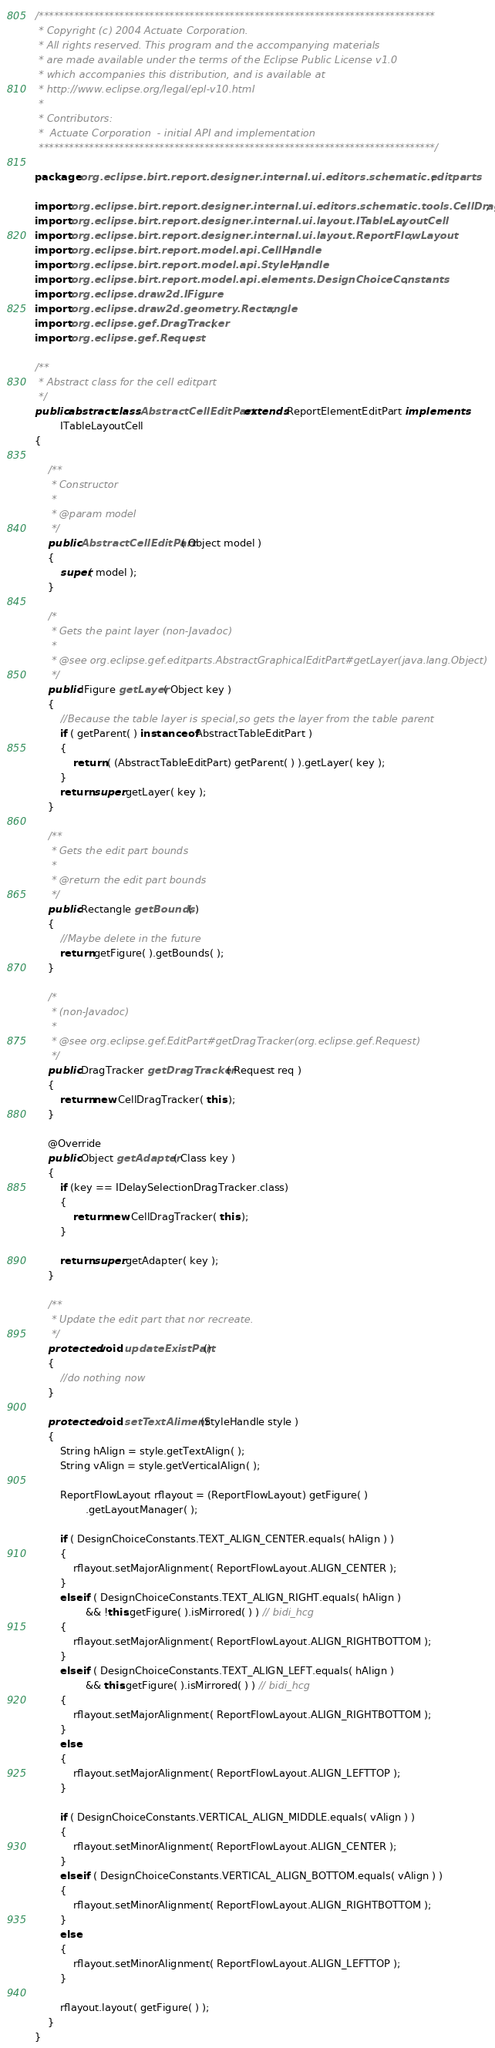<code> <loc_0><loc_0><loc_500><loc_500><_Java_>/*******************************************************************************
 * Copyright (c) 2004 Actuate Corporation.
 * All rights reserved. This program and the accompanying materials
 * are made available under the terms of the Eclipse Public License v1.0
 * which accompanies this distribution, and is available at
 * http://www.eclipse.org/legal/epl-v10.html
 *
 * Contributors:
 *  Actuate Corporation  - initial API and implementation
 *******************************************************************************/

package org.eclipse.birt.report.designer.internal.ui.editors.schematic.editparts;

import org.eclipse.birt.report.designer.internal.ui.editors.schematic.tools.CellDragTracker;
import org.eclipse.birt.report.designer.internal.ui.layout.ITableLayoutCell;
import org.eclipse.birt.report.designer.internal.ui.layout.ReportFlowLayout;
import org.eclipse.birt.report.model.api.CellHandle;
import org.eclipse.birt.report.model.api.StyleHandle;
import org.eclipse.birt.report.model.api.elements.DesignChoiceConstants;
import org.eclipse.draw2d.IFigure;
import org.eclipse.draw2d.geometry.Rectangle;
import org.eclipse.gef.DragTracker;
import org.eclipse.gef.Request;

/**
 * Abstract class for the cell editpart
 */
public abstract class AbstractCellEditPart extends ReportElementEditPart implements
		ITableLayoutCell
{

	/**
	 * Constructor
	 * 
	 * @param model
	 */
	public AbstractCellEditPart( Object model )
	{
		super( model );
	}

	/*
	 * Gets the paint layer (non-Javadoc)
	 * 
	 * @see org.eclipse.gef.editparts.AbstractGraphicalEditPart#getLayer(java.lang.Object)
	 */
	public IFigure getLayer( Object key )
	{
		//Because the table layer is special,so gets the layer from the table parent
		if ( getParent( ) instanceof AbstractTableEditPart )
		{
			return ( (AbstractTableEditPart) getParent( ) ).getLayer( key );
		}
		return super.getLayer( key );
	}

	/**
	 * Gets the edit part bounds
	 * 
	 * @return the edit part bounds
	 */
	public Rectangle getBounds( )
	{
		//Maybe delete in the future
		return getFigure( ).getBounds( );
	}
		
	/*
	 * (non-Javadoc)
	 * 
	 * @see org.eclipse.gef.EditPart#getDragTracker(org.eclipse.gef.Request)
	 */
	public DragTracker getDragTracker( Request req )
	{
		return new CellDragTracker( this );
	}
	
	@Override
	public Object getAdapter( Class key )
	{
		if (key == IDelaySelectionDragTracker.class)
		{
			return new CellDragTracker( this );
		}
			
		return super.getAdapter( key );
	}
	
	/**
	 * Update the edit part that nor recreate.
	 */
	protected void updateExistPart()
	{
		//do nothing now
	}
	
	protected void setTextAliment(StyleHandle style )
	{
		String hAlign = style.getTextAlign( );
		String vAlign = style.getVerticalAlign( );

		ReportFlowLayout rflayout = (ReportFlowLayout) getFigure( )
				.getLayoutManager( );

		if ( DesignChoiceConstants.TEXT_ALIGN_CENTER.equals( hAlign ) )
		{
			rflayout.setMajorAlignment( ReportFlowLayout.ALIGN_CENTER );
		}
		else if ( DesignChoiceConstants.TEXT_ALIGN_RIGHT.equals( hAlign ) 
				&& !this.getFigure( ).isMirrored( ) ) // bidi_hcg
		{
			rflayout.setMajorAlignment( ReportFlowLayout.ALIGN_RIGHTBOTTOM );
		}
		else if ( DesignChoiceConstants.TEXT_ALIGN_LEFT.equals( hAlign ) 
				&& this.getFigure( ).isMirrored( ) ) // bidi_hcg
		{
			rflayout.setMajorAlignment( ReportFlowLayout.ALIGN_RIGHTBOTTOM );
		}
		else
		{
			rflayout.setMajorAlignment( ReportFlowLayout.ALIGN_LEFTTOP );
		}

		if ( DesignChoiceConstants.VERTICAL_ALIGN_MIDDLE.equals( vAlign ) )
		{
			rflayout.setMinorAlignment( ReportFlowLayout.ALIGN_CENTER );
		}
		else if ( DesignChoiceConstants.VERTICAL_ALIGN_BOTTOM.equals( vAlign ) )
		{
			rflayout.setMinorAlignment( ReportFlowLayout.ALIGN_RIGHTBOTTOM );
		}
		else
		{
			rflayout.setMinorAlignment( ReportFlowLayout.ALIGN_LEFTTOP );
		}
		
		rflayout.layout( getFigure( ) );
	}
}
</code> 